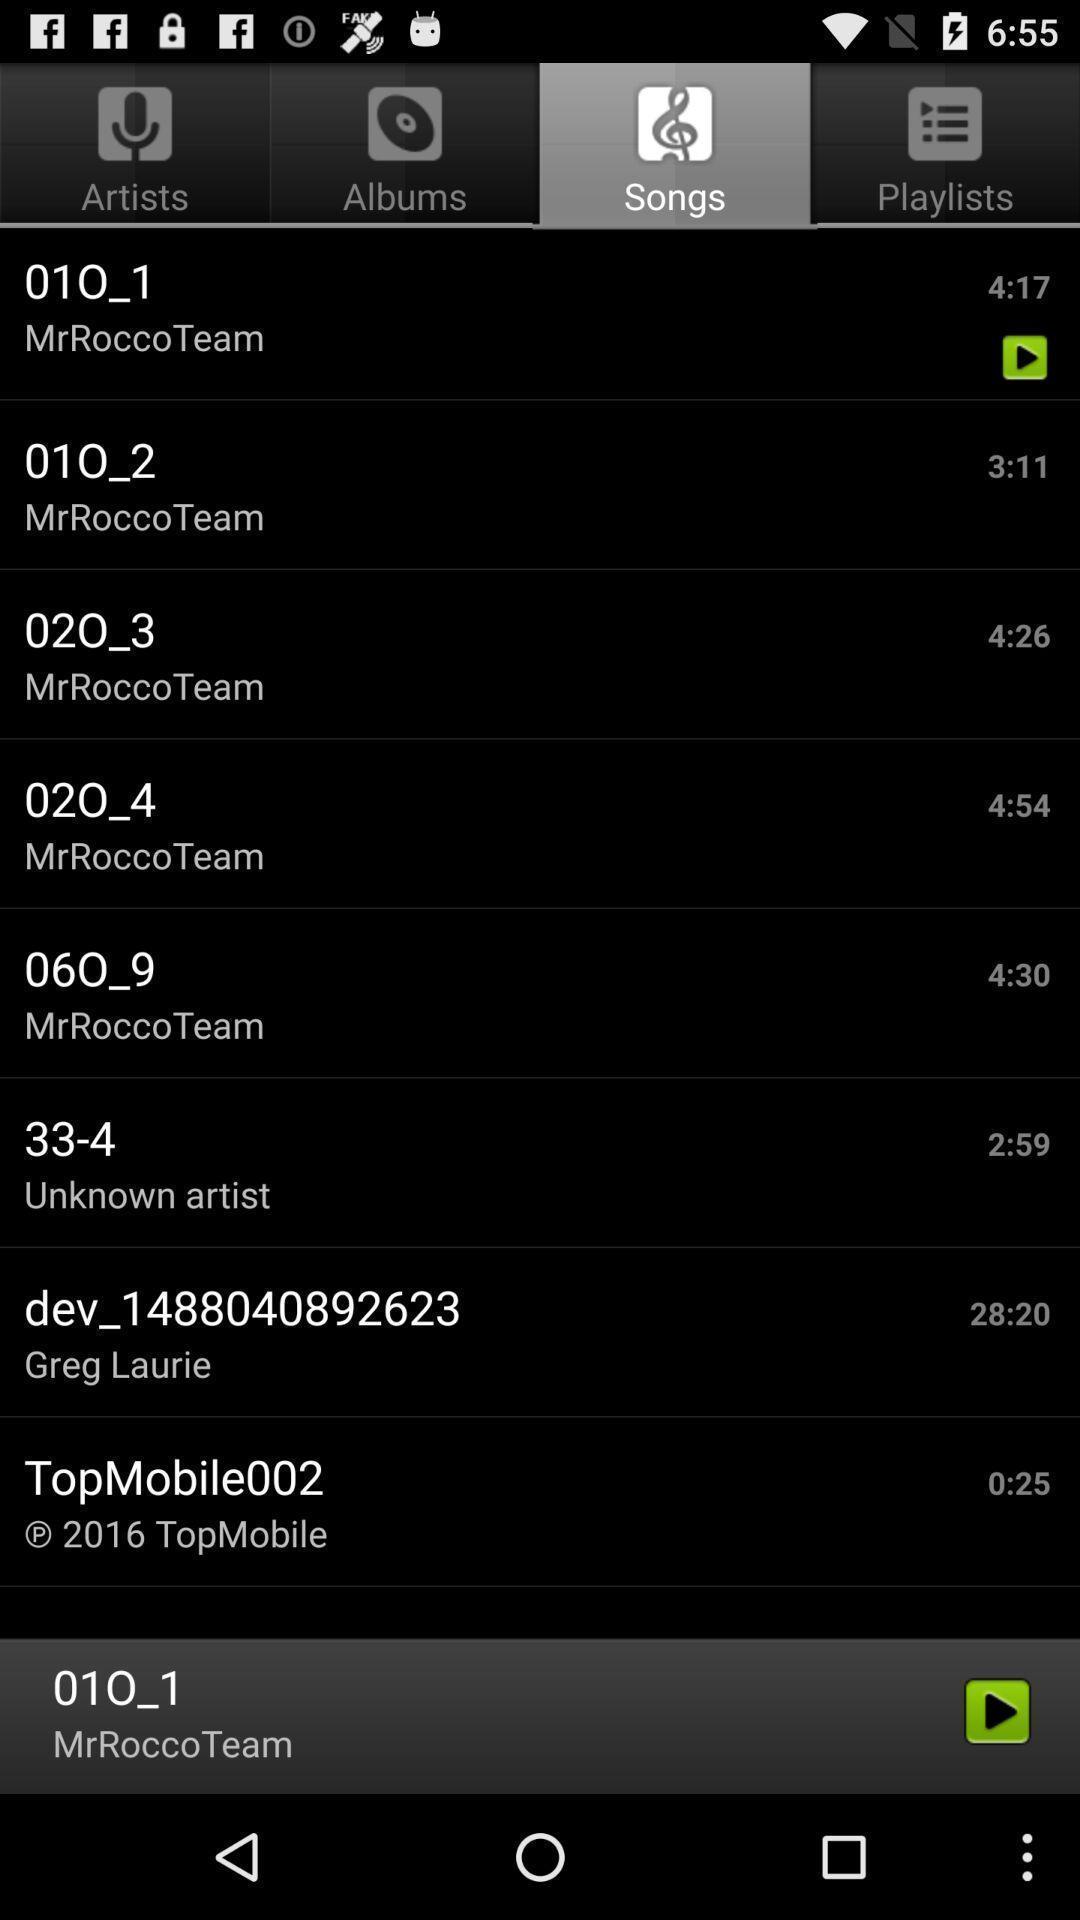Please provide a description for this image. Various types of songs in the music app. 